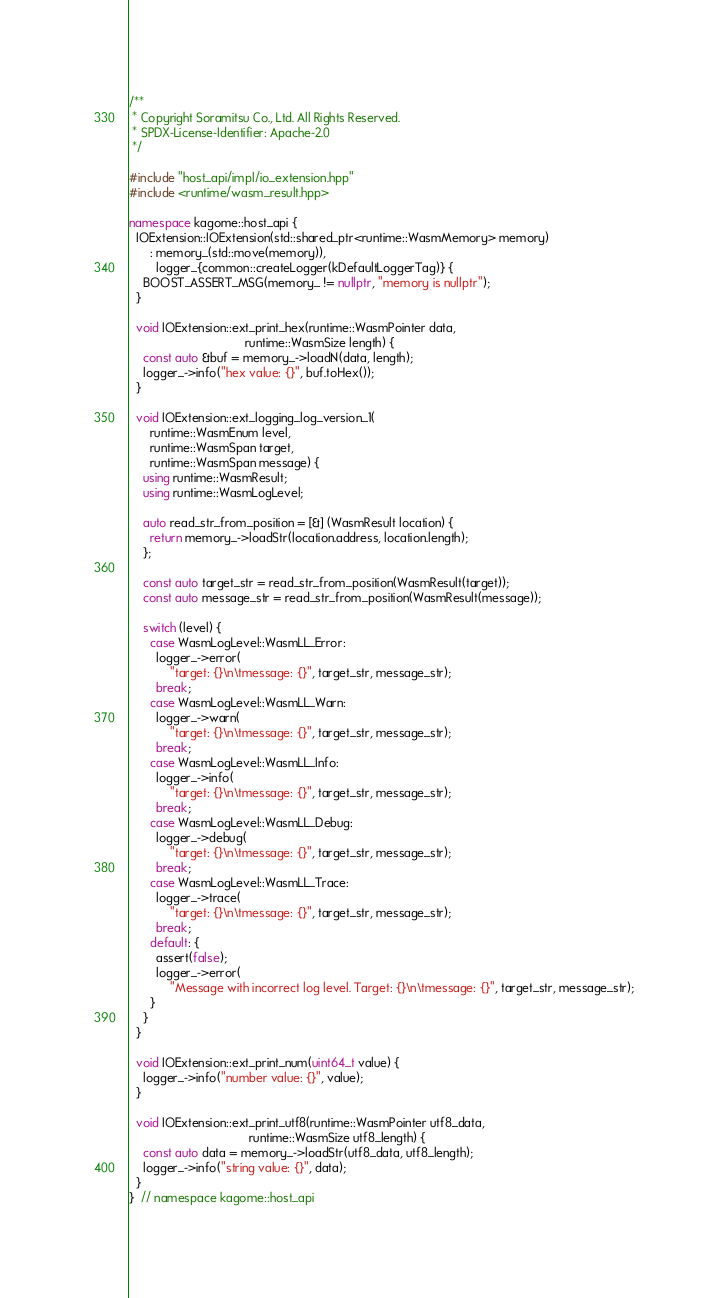Convert code to text. <code><loc_0><loc_0><loc_500><loc_500><_C++_>/**
 * Copyright Soramitsu Co., Ltd. All Rights Reserved.
 * SPDX-License-Identifier: Apache-2.0
 */

#include "host_api/impl/io_extension.hpp"
#include <runtime/wasm_result.hpp>

namespace kagome::host_api {
  IOExtension::IOExtension(std::shared_ptr<runtime::WasmMemory> memory)
      : memory_(std::move(memory)),
        logger_{common::createLogger(kDefaultLoggerTag)} {
    BOOST_ASSERT_MSG(memory_ != nullptr, "memory is nullptr");
  }

  void IOExtension::ext_print_hex(runtime::WasmPointer data,
                                  runtime::WasmSize length) {
    const auto &buf = memory_->loadN(data, length);
    logger_->info("hex value: {}", buf.toHex());
  }

  void IOExtension::ext_logging_log_version_1(
      runtime::WasmEnum level,
      runtime::WasmSpan target,
      runtime::WasmSpan message) {
    using runtime::WasmResult;
    using runtime::WasmLogLevel;

    auto read_str_from_position = [&] (WasmResult location) {
      return memory_->loadStr(location.address, location.length);
    };

    const auto target_str = read_str_from_position(WasmResult(target));
    const auto message_str = read_str_from_position(WasmResult(message));

    switch (level) {
      case WasmLogLevel::WasmLL_Error:
        logger_->error(
            "target: {}\n\tmessage: {}", target_str, message_str);
        break;
      case WasmLogLevel::WasmLL_Warn:
        logger_->warn(
            "target: {}\n\tmessage: {}", target_str, message_str);
        break;
      case WasmLogLevel::WasmLL_Info:
        logger_->info(
            "target: {}\n\tmessage: {}", target_str, message_str);
        break;
      case WasmLogLevel::WasmLL_Debug:
        logger_->debug(
            "target: {}\n\tmessage: {}", target_str, message_str);
        break;
      case WasmLogLevel::WasmLL_Trace:
        logger_->trace(
            "target: {}\n\tmessage: {}", target_str, message_str);
        break;
      default: {
        assert(false);
        logger_->error(
            "Message with incorrect log level. Target: {}\n\tmessage: {}", target_str, message_str);
      }
    }
  }

  void IOExtension::ext_print_num(uint64_t value) {
    logger_->info("number value: {}", value);
  }

  void IOExtension::ext_print_utf8(runtime::WasmPointer utf8_data,
                                   runtime::WasmSize utf8_length) {
    const auto data = memory_->loadStr(utf8_data, utf8_length);
    logger_->info("string value: {}", data);
  }
}  // namespace kagome::host_api
</code> 